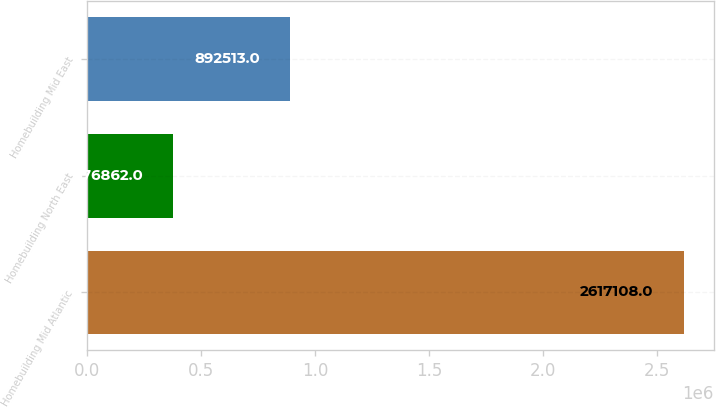Convert chart. <chart><loc_0><loc_0><loc_500><loc_500><bar_chart><fcel>Homebuilding Mid Atlantic<fcel>Homebuilding North East<fcel>Homebuilding Mid East<nl><fcel>2.61711e+06<fcel>376862<fcel>892513<nl></chart> 